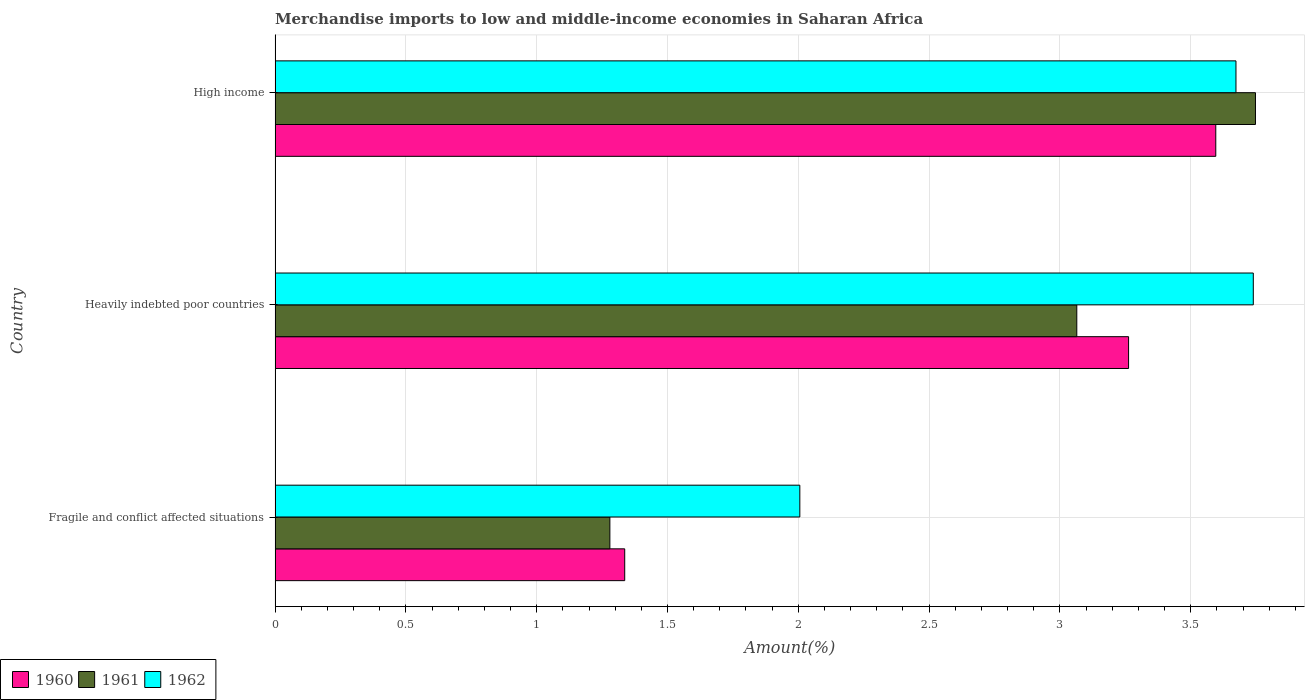How many different coloured bars are there?
Your answer should be compact. 3. How many groups of bars are there?
Give a very brief answer. 3. Are the number of bars per tick equal to the number of legend labels?
Your answer should be compact. Yes. How many bars are there on the 2nd tick from the top?
Your answer should be very brief. 3. What is the percentage of amount earned from merchandise imports in 1961 in Fragile and conflict affected situations?
Offer a very short reply. 1.28. Across all countries, what is the maximum percentage of amount earned from merchandise imports in 1961?
Provide a short and direct response. 3.75. Across all countries, what is the minimum percentage of amount earned from merchandise imports in 1962?
Your answer should be very brief. 2.01. In which country was the percentage of amount earned from merchandise imports in 1962 minimum?
Ensure brevity in your answer.  Fragile and conflict affected situations. What is the total percentage of amount earned from merchandise imports in 1961 in the graph?
Your answer should be compact. 8.09. What is the difference between the percentage of amount earned from merchandise imports in 1961 in Heavily indebted poor countries and that in High income?
Provide a short and direct response. -0.68. What is the difference between the percentage of amount earned from merchandise imports in 1962 in Heavily indebted poor countries and the percentage of amount earned from merchandise imports in 1960 in High income?
Keep it short and to the point. 0.14. What is the average percentage of amount earned from merchandise imports in 1962 per country?
Ensure brevity in your answer.  3.14. What is the difference between the percentage of amount earned from merchandise imports in 1962 and percentage of amount earned from merchandise imports in 1960 in Heavily indebted poor countries?
Provide a succinct answer. 0.48. What is the ratio of the percentage of amount earned from merchandise imports in 1962 in Fragile and conflict affected situations to that in High income?
Keep it short and to the point. 0.55. What is the difference between the highest and the second highest percentage of amount earned from merchandise imports in 1960?
Ensure brevity in your answer.  0.33. What is the difference between the highest and the lowest percentage of amount earned from merchandise imports in 1960?
Provide a succinct answer. 2.26. Is the sum of the percentage of amount earned from merchandise imports in 1960 in Fragile and conflict affected situations and High income greater than the maximum percentage of amount earned from merchandise imports in 1962 across all countries?
Your response must be concise. Yes. What does the 3rd bar from the top in Fragile and conflict affected situations represents?
Your response must be concise. 1960. What does the 2nd bar from the bottom in Heavily indebted poor countries represents?
Ensure brevity in your answer.  1961. How many countries are there in the graph?
Provide a short and direct response. 3. Are the values on the major ticks of X-axis written in scientific E-notation?
Your answer should be very brief. No. Does the graph contain any zero values?
Provide a short and direct response. No. Where does the legend appear in the graph?
Keep it short and to the point. Bottom left. How many legend labels are there?
Provide a short and direct response. 3. How are the legend labels stacked?
Give a very brief answer. Horizontal. What is the title of the graph?
Ensure brevity in your answer.  Merchandise imports to low and middle-income economies in Saharan Africa. What is the label or title of the X-axis?
Provide a succinct answer. Amount(%). What is the Amount(%) of 1960 in Fragile and conflict affected situations?
Offer a very short reply. 1.34. What is the Amount(%) in 1961 in Fragile and conflict affected situations?
Keep it short and to the point. 1.28. What is the Amount(%) of 1962 in Fragile and conflict affected situations?
Give a very brief answer. 2.01. What is the Amount(%) in 1960 in Heavily indebted poor countries?
Offer a very short reply. 3.26. What is the Amount(%) of 1961 in Heavily indebted poor countries?
Provide a succinct answer. 3.06. What is the Amount(%) in 1962 in Heavily indebted poor countries?
Your answer should be very brief. 3.74. What is the Amount(%) in 1960 in High income?
Ensure brevity in your answer.  3.6. What is the Amount(%) in 1961 in High income?
Your answer should be very brief. 3.75. What is the Amount(%) in 1962 in High income?
Ensure brevity in your answer.  3.67. Across all countries, what is the maximum Amount(%) in 1960?
Your answer should be compact. 3.6. Across all countries, what is the maximum Amount(%) in 1961?
Your answer should be very brief. 3.75. Across all countries, what is the maximum Amount(%) in 1962?
Keep it short and to the point. 3.74. Across all countries, what is the minimum Amount(%) of 1960?
Ensure brevity in your answer.  1.34. Across all countries, what is the minimum Amount(%) in 1961?
Make the answer very short. 1.28. Across all countries, what is the minimum Amount(%) in 1962?
Your response must be concise. 2.01. What is the total Amount(%) in 1960 in the graph?
Give a very brief answer. 8.2. What is the total Amount(%) in 1961 in the graph?
Your answer should be very brief. 8.09. What is the total Amount(%) in 1962 in the graph?
Provide a short and direct response. 9.42. What is the difference between the Amount(%) of 1960 in Fragile and conflict affected situations and that in Heavily indebted poor countries?
Give a very brief answer. -1.93. What is the difference between the Amount(%) of 1961 in Fragile and conflict affected situations and that in Heavily indebted poor countries?
Offer a terse response. -1.78. What is the difference between the Amount(%) of 1962 in Fragile and conflict affected situations and that in Heavily indebted poor countries?
Your answer should be very brief. -1.73. What is the difference between the Amount(%) of 1960 in Fragile and conflict affected situations and that in High income?
Make the answer very short. -2.26. What is the difference between the Amount(%) of 1961 in Fragile and conflict affected situations and that in High income?
Give a very brief answer. -2.47. What is the difference between the Amount(%) in 1962 in Fragile and conflict affected situations and that in High income?
Keep it short and to the point. -1.67. What is the difference between the Amount(%) of 1960 in Heavily indebted poor countries and that in High income?
Ensure brevity in your answer.  -0.33. What is the difference between the Amount(%) in 1961 in Heavily indebted poor countries and that in High income?
Ensure brevity in your answer.  -0.68. What is the difference between the Amount(%) in 1962 in Heavily indebted poor countries and that in High income?
Provide a short and direct response. 0.07. What is the difference between the Amount(%) in 1960 in Fragile and conflict affected situations and the Amount(%) in 1961 in Heavily indebted poor countries?
Provide a short and direct response. -1.73. What is the difference between the Amount(%) in 1960 in Fragile and conflict affected situations and the Amount(%) in 1962 in Heavily indebted poor countries?
Provide a short and direct response. -2.4. What is the difference between the Amount(%) in 1961 in Fragile and conflict affected situations and the Amount(%) in 1962 in Heavily indebted poor countries?
Your answer should be very brief. -2.46. What is the difference between the Amount(%) in 1960 in Fragile and conflict affected situations and the Amount(%) in 1961 in High income?
Your answer should be compact. -2.41. What is the difference between the Amount(%) in 1960 in Fragile and conflict affected situations and the Amount(%) in 1962 in High income?
Your response must be concise. -2.34. What is the difference between the Amount(%) of 1961 in Fragile and conflict affected situations and the Amount(%) of 1962 in High income?
Provide a short and direct response. -2.39. What is the difference between the Amount(%) in 1960 in Heavily indebted poor countries and the Amount(%) in 1961 in High income?
Offer a terse response. -0.49. What is the difference between the Amount(%) in 1960 in Heavily indebted poor countries and the Amount(%) in 1962 in High income?
Ensure brevity in your answer.  -0.41. What is the difference between the Amount(%) of 1961 in Heavily indebted poor countries and the Amount(%) of 1962 in High income?
Offer a terse response. -0.61. What is the average Amount(%) in 1960 per country?
Your response must be concise. 2.73. What is the average Amount(%) of 1961 per country?
Your answer should be very brief. 2.7. What is the average Amount(%) of 1962 per country?
Provide a succinct answer. 3.14. What is the difference between the Amount(%) of 1960 and Amount(%) of 1961 in Fragile and conflict affected situations?
Offer a terse response. 0.06. What is the difference between the Amount(%) of 1960 and Amount(%) of 1962 in Fragile and conflict affected situations?
Provide a succinct answer. -0.67. What is the difference between the Amount(%) of 1961 and Amount(%) of 1962 in Fragile and conflict affected situations?
Your answer should be compact. -0.73. What is the difference between the Amount(%) in 1960 and Amount(%) in 1961 in Heavily indebted poor countries?
Offer a very short reply. 0.2. What is the difference between the Amount(%) in 1960 and Amount(%) in 1962 in Heavily indebted poor countries?
Your response must be concise. -0.48. What is the difference between the Amount(%) of 1961 and Amount(%) of 1962 in Heavily indebted poor countries?
Offer a terse response. -0.67. What is the difference between the Amount(%) of 1960 and Amount(%) of 1961 in High income?
Offer a very short reply. -0.15. What is the difference between the Amount(%) in 1960 and Amount(%) in 1962 in High income?
Your response must be concise. -0.08. What is the difference between the Amount(%) of 1961 and Amount(%) of 1962 in High income?
Your answer should be very brief. 0.07. What is the ratio of the Amount(%) of 1960 in Fragile and conflict affected situations to that in Heavily indebted poor countries?
Your answer should be compact. 0.41. What is the ratio of the Amount(%) of 1961 in Fragile and conflict affected situations to that in Heavily indebted poor countries?
Provide a succinct answer. 0.42. What is the ratio of the Amount(%) in 1962 in Fragile and conflict affected situations to that in Heavily indebted poor countries?
Your answer should be compact. 0.54. What is the ratio of the Amount(%) in 1960 in Fragile and conflict affected situations to that in High income?
Offer a very short reply. 0.37. What is the ratio of the Amount(%) of 1961 in Fragile and conflict affected situations to that in High income?
Provide a succinct answer. 0.34. What is the ratio of the Amount(%) in 1962 in Fragile and conflict affected situations to that in High income?
Your answer should be compact. 0.55. What is the ratio of the Amount(%) in 1960 in Heavily indebted poor countries to that in High income?
Make the answer very short. 0.91. What is the ratio of the Amount(%) of 1961 in Heavily indebted poor countries to that in High income?
Offer a very short reply. 0.82. What is the difference between the highest and the second highest Amount(%) of 1960?
Provide a succinct answer. 0.33. What is the difference between the highest and the second highest Amount(%) in 1961?
Offer a very short reply. 0.68. What is the difference between the highest and the second highest Amount(%) of 1962?
Offer a very short reply. 0.07. What is the difference between the highest and the lowest Amount(%) of 1960?
Your answer should be very brief. 2.26. What is the difference between the highest and the lowest Amount(%) in 1961?
Give a very brief answer. 2.47. What is the difference between the highest and the lowest Amount(%) in 1962?
Offer a terse response. 1.73. 